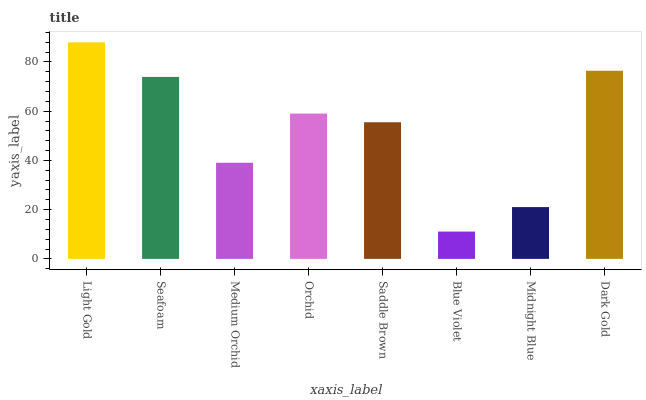Is Blue Violet the minimum?
Answer yes or no. Yes. Is Light Gold the maximum?
Answer yes or no. Yes. Is Seafoam the minimum?
Answer yes or no. No. Is Seafoam the maximum?
Answer yes or no. No. Is Light Gold greater than Seafoam?
Answer yes or no. Yes. Is Seafoam less than Light Gold?
Answer yes or no. Yes. Is Seafoam greater than Light Gold?
Answer yes or no. No. Is Light Gold less than Seafoam?
Answer yes or no. No. Is Orchid the high median?
Answer yes or no. Yes. Is Saddle Brown the low median?
Answer yes or no. Yes. Is Blue Violet the high median?
Answer yes or no. No. Is Blue Violet the low median?
Answer yes or no. No. 